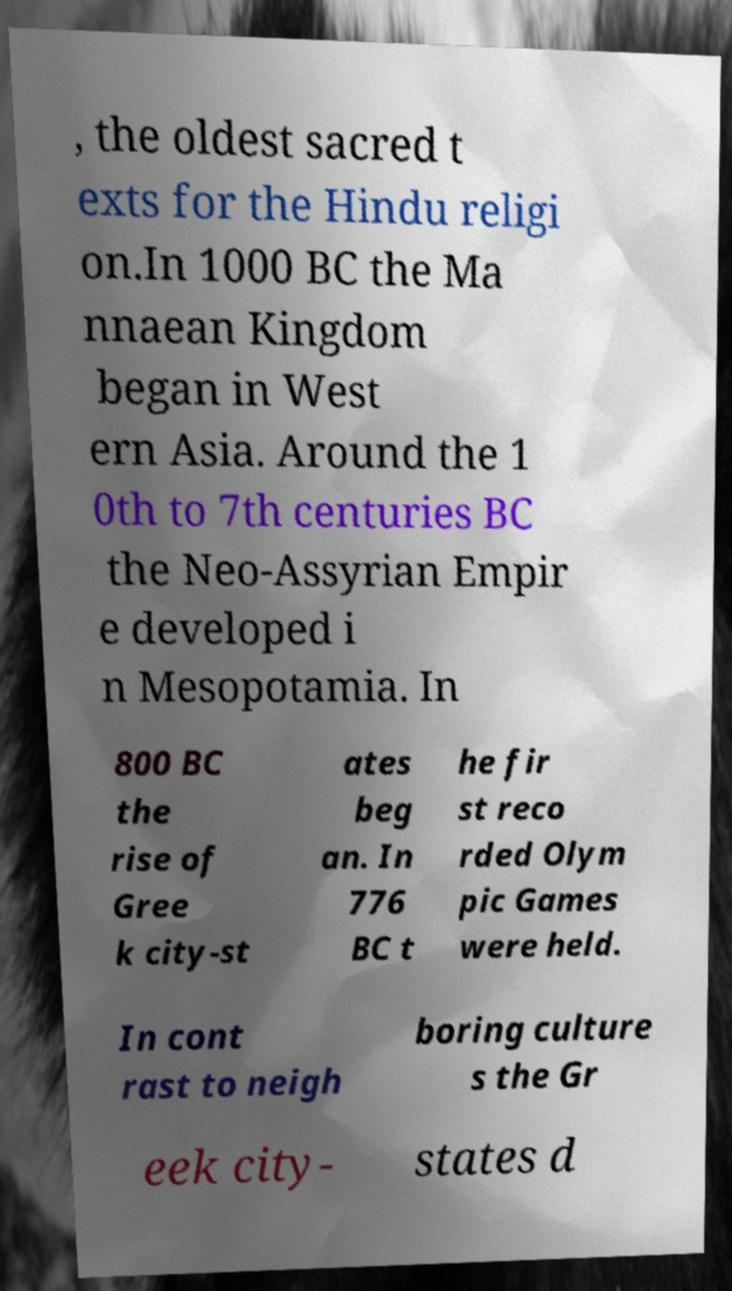For documentation purposes, I need the text within this image transcribed. Could you provide that? , the oldest sacred t exts for the Hindu religi on.In 1000 BC the Ma nnaean Kingdom began in West ern Asia. Around the 1 0th to 7th centuries BC the Neo-Assyrian Empir e developed i n Mesopotamia. In 800 BC the rise of Gree k city-st ates beg an. In 776 BC t he fir st reco rded Olym pic Games were held. In cont rast to neigh boring culture s the Gr eek city- states d 